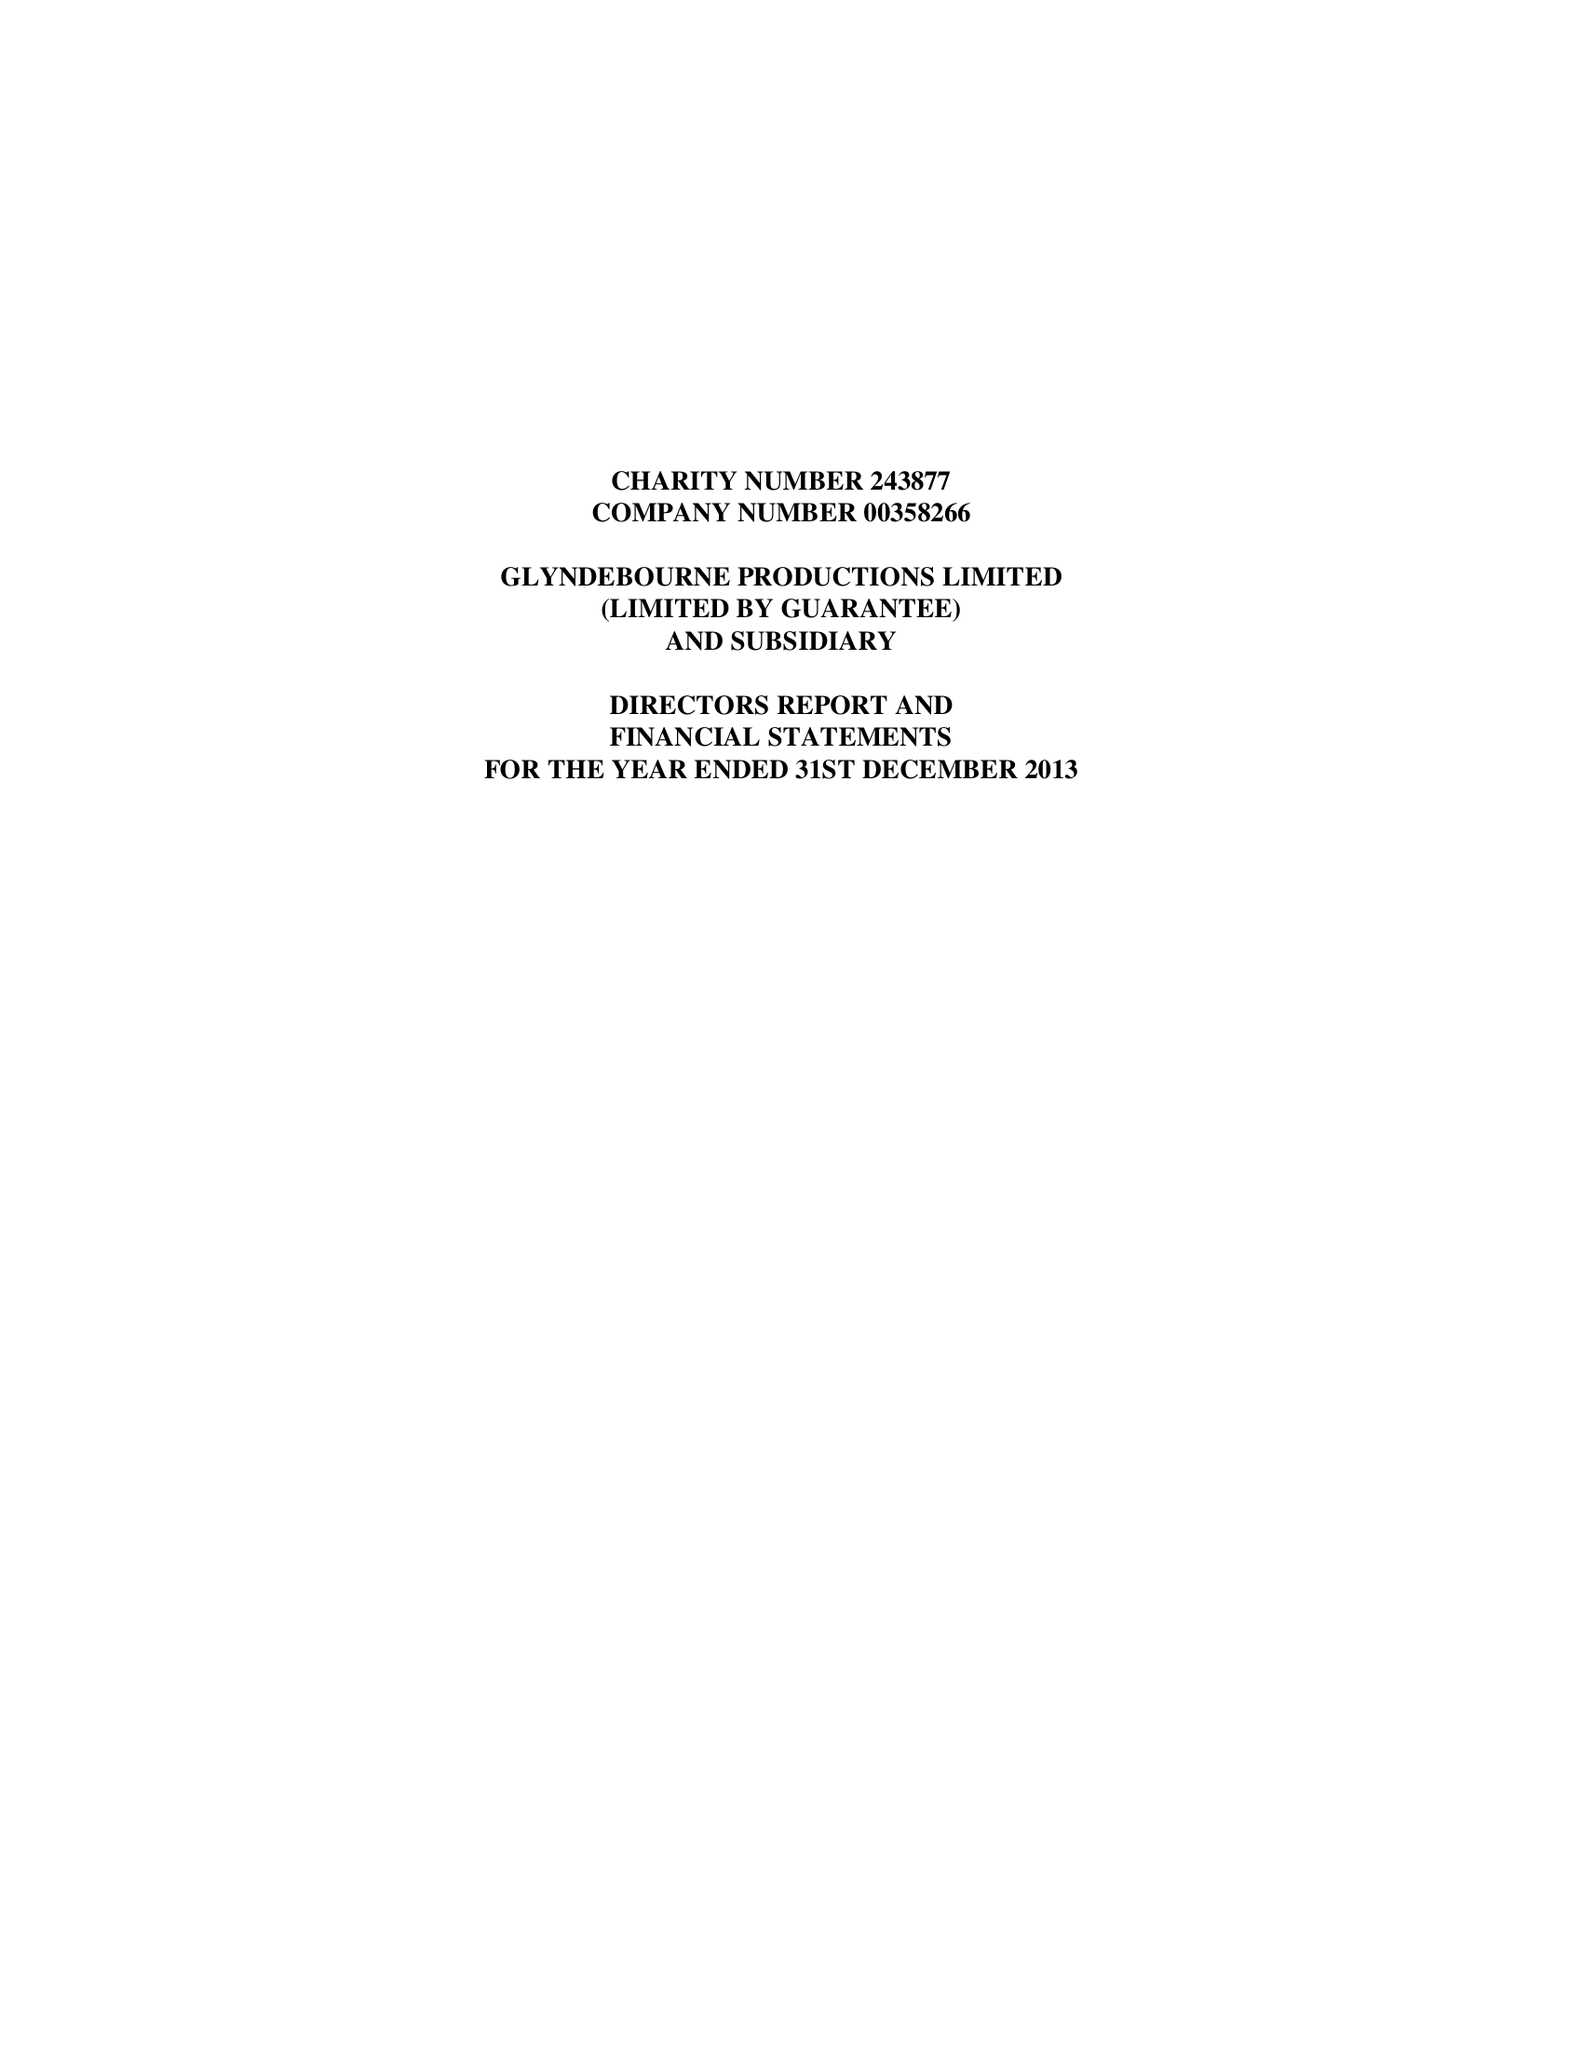What is the value for the charity_name?
Answer the question using a single word or phrase. Glyndebourne Productions Ltd. 